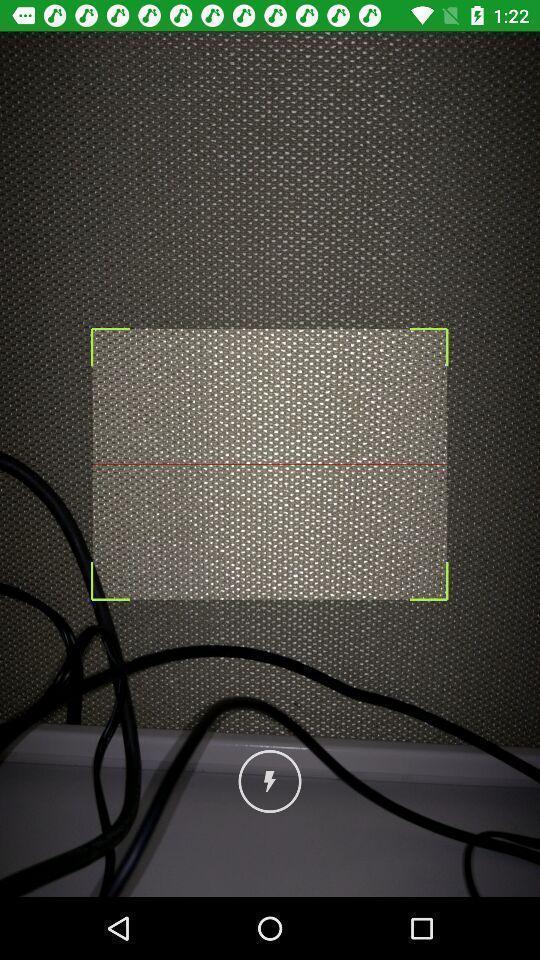Describe the visual elements of this screenshot. Taking a photo in a camera. 